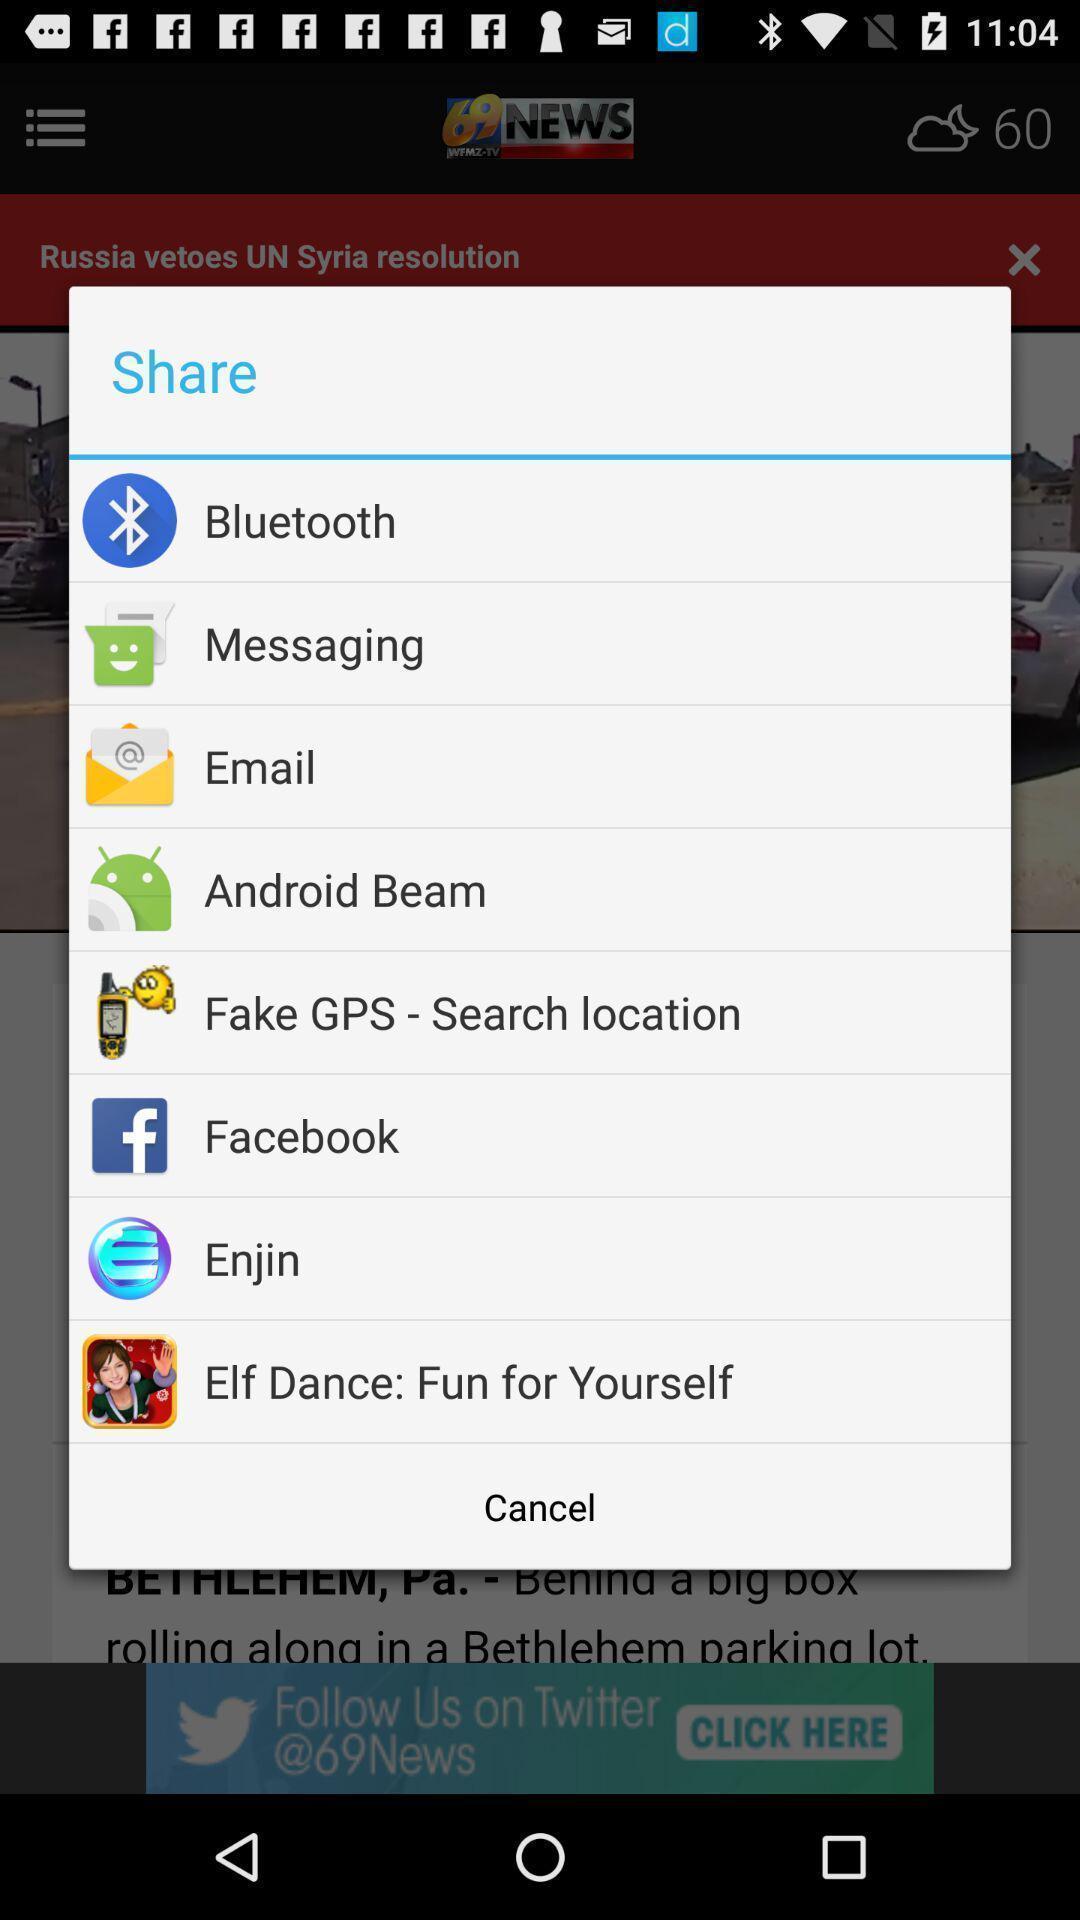Tell me what you see in this picture. Popup of applications to share the information. 